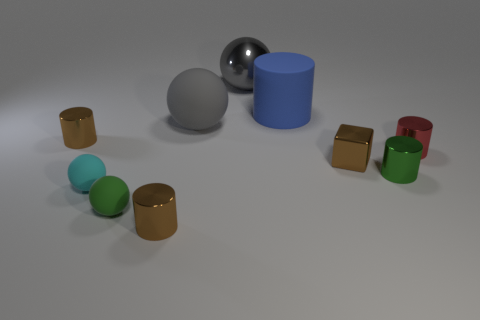There is a matte thing that is the same color as the shiny ball; what is its shape?
Your response must be concise. Sphere. Is the color of the block the same as the big matte sphere?
Your response must be concise. No. What size is the cube?
Give a very brief answer. Small. What number of large rubber cylinders have the same color as the big rubber sphere?
Offer a terse response. 0. There is a brown metallic cylinder in front of the tiny brown cylinder behind the green cylinder; are there any rubber cylinders that are in front of it?
Your answer should be very brief. No. The green matte thing that is the same size as the green shiny cylinder is what shape?
Provide a short and direct response. Sphere. How many tiny objects are brown things or metallic cylinders?
Make the answer very short. 5. What color is the large ball that is made of the same material as the big blue thing?
Give a very brief answer. Gray. There is a tiny green thing on the right side of the green matte ball; is its shape the same as the object that is on the left side of the small cyan ball?
Keep it short and to the point. Yes. How many metallic things are either gray blocks or small green cylinders?
Make the answer very short. 1. 